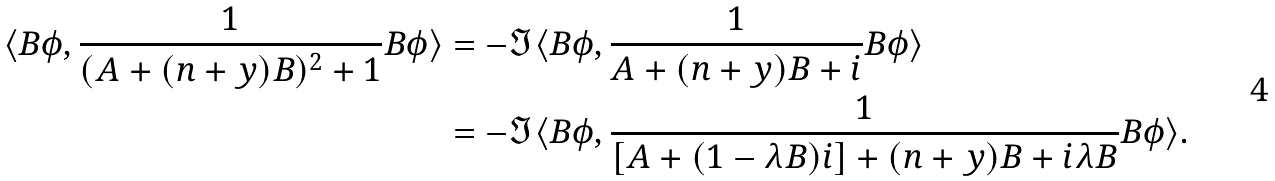<formula> <loc_0><loc_0><loc_500><loc_500>\langle B \phi , \frac { 1 } { ( A + ( n + y ) B ) ^ { 2 } + 1 } B \phi \rangle & = - \Im \langle B \phi , \frac { 1 } { A + ( n + y ) B + i } B \phi \rangle \\ & = - \Im \langle B \phi , \frac { 1 } { [ A + ( 1 - \lambda B ) i ] + ( n + y ) B + i \lambda B } B \phi \rangle .</formula> 